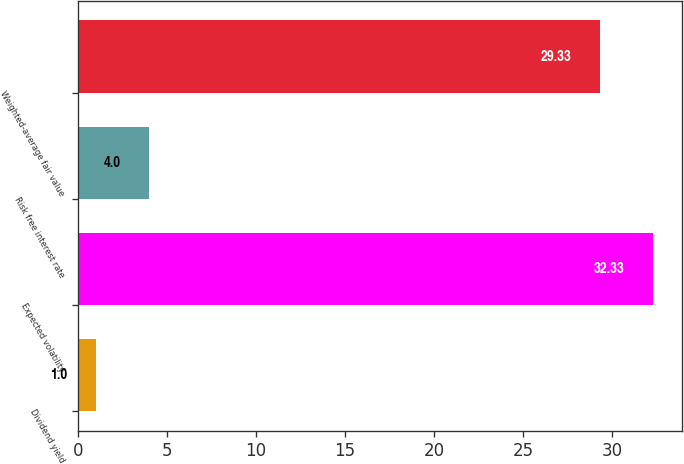Convert chart to OTSL. <chart><loc_0><loc_0><loc_500><loc_500><bar_chart><fcel>Dividend yield<fcel>Expected volatility<fcel>Risk free interest rate<fcel>Weighted-average fair value<nl><fcel>1<fcel>32.33<fcel>4<fcel>29.33<nl></chart> 